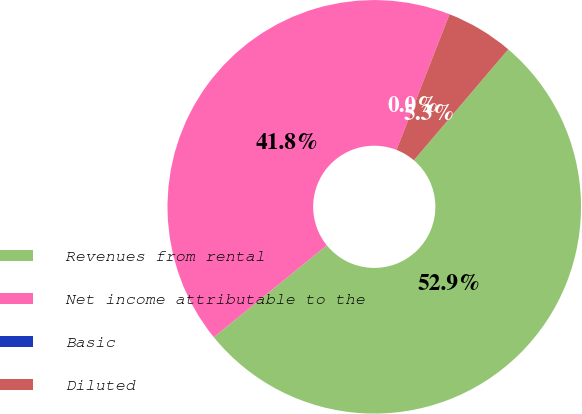Convert chart to OTSL. <chart><loc_0><loc_0><loc_500><loc_500><pie_chart><fcel>Revenues from rental<fcel>Net income attributable to the<fcel>Basic<fcel>Diluted<nl><fcel>52.92%<fcel>41.79%<fcel>0.0%<fcel>5.29%<nl></chart> 